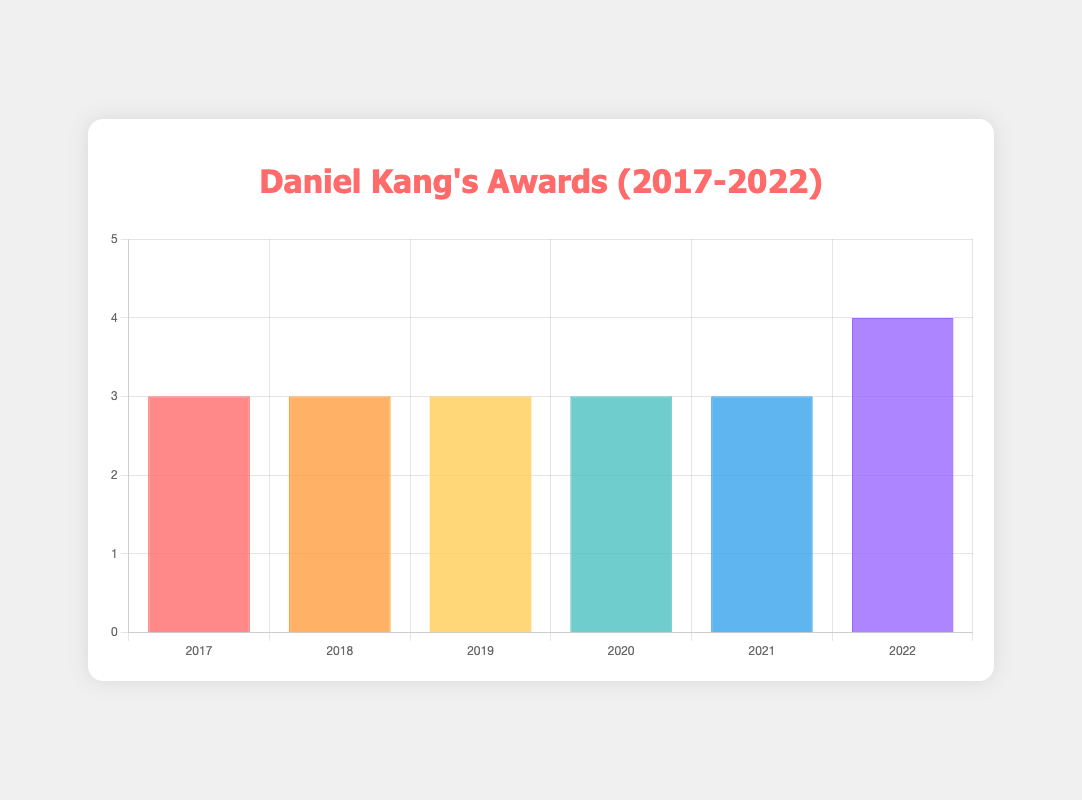Which year did Daniel Kang win the most awards? In the bar chart, the height of the bar for each year represents the number of awards won. By comparing the heights, we can see that the year 2022 has the highest bar.
Answer: 2022 Which years did Daniel Kang win exactly three awards? By checking the heights of the bars in the chart, we can identify the years where the bar height is 3. These years are 2017, 2018, 2019, 2020, and 2021.
Answer: 2017, 2018, 2019, 2020, 2021 How many awards in total did Daniel Kang win from 2017 to 2022? Sum the number of awards for each year as represented by the heights of the bars: 3 (2017) + 3 (2018) + 3 (2019) + 3 (2020) + 3 (2021) + 4 (2022) = 19.
Answer: 19 Which year had more awards: 2018 or 2020? Compare the heights of the bars for the years 2018 and 2020. Both bars are of equal height, indicating that Daniel Kang won the same number of awards in both years.
Answer: Equal Of which type did Daniel Kang win the most awards in 2022? Examine the tooltip displayed for the year 2022 bar. It lists the types and names of the awards won. Melon Music Awards have been won the most frequently in 2022.
Answer: Melon Music Awards Which two consecutive years have the same number of awards? By comparing the bar heights for consecutive years, we see that 2018 and 2019 both have a bar height of 3.
Answer: 2018 and 2019 